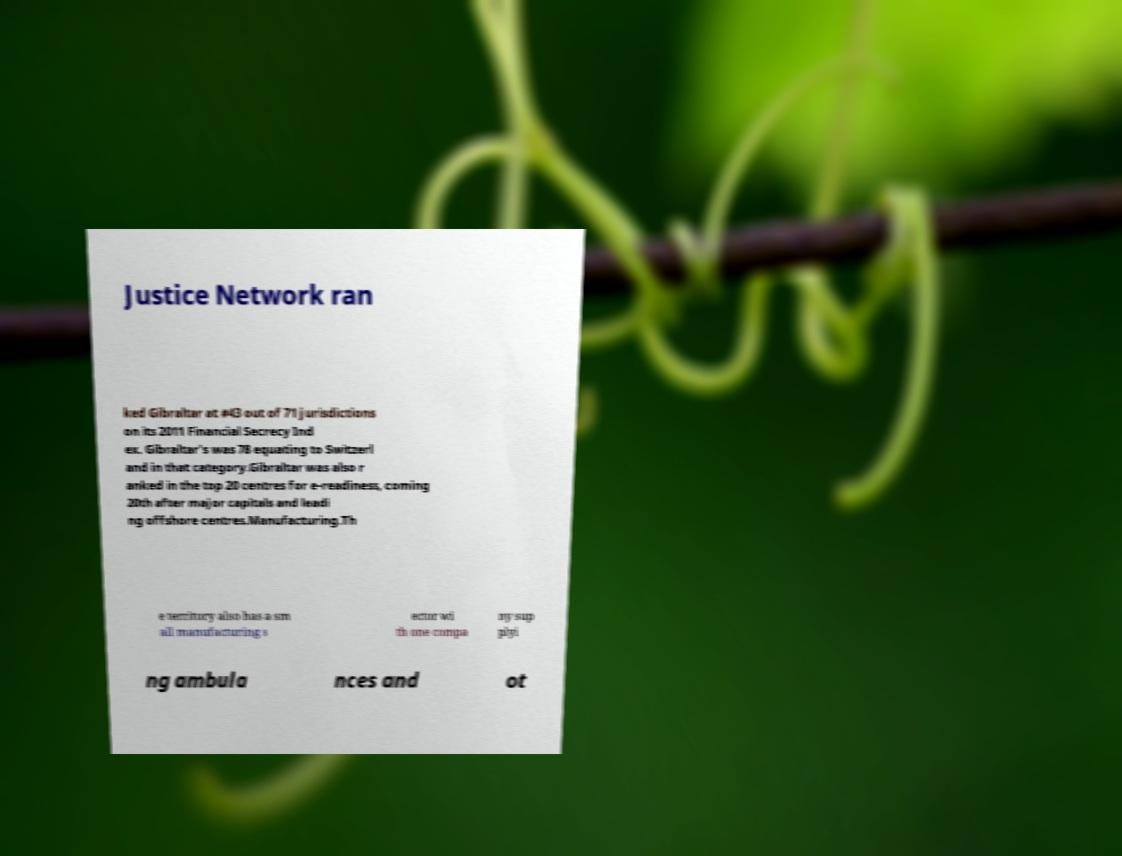Could you extract and type out the text from this image? Justice Network ran ked Gibraltar at #43 out of 71 jurisdictions on its 2011 Financial Secrecy Ind ex. Gibraltar's was 78 equating to Switzerl and in that category.Gibraltar was also r anked in the top 20 centres for e-readiness, coming 20th after major capitals and leadi ng offshore centres.Manufacturing.Th e territory also has a sm all manufacturing s ector wi th one compa ny sup plyi ng ambula nces and ot 